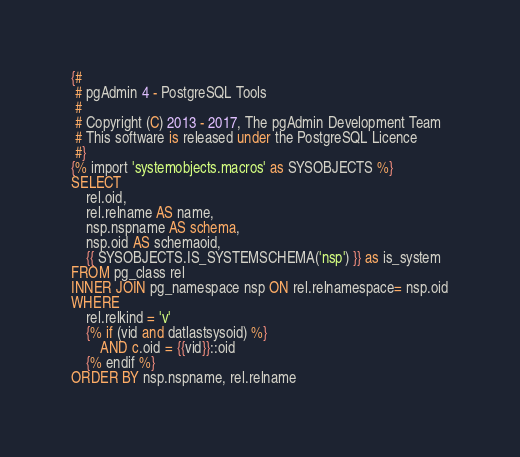Convert code to text. <code><loc_0><loc_0><loc_500><loc_500><_SQL_>{#
 # pgAdmin 4 - PostgreSQL Tools
 #
 # Copyright (C) 2013 - 2017, The pgAdmin Development Team
 # This software is released under the PostgreSQL Licence
 #}
{% import 'systemobjects.macros' as SYSOBJECTS %} 
SELECT
    rel.oid,
    rel.relname AS name,
    nsp.nspname AS schema,
    nsp.oid AS schemaoid,
    {{ SYSOBJECTS.IS_SYSTEMSCHEMA('nsp') }} as is_system
FROM pg_class rel
INNER JOIN pg_namespace nsp ON rel.relnamespace= nsp.oid
WHERE
    rel.relkind = 'v'
    {% if (vid and datlastsysoid) %}
        AND c.oid = {{vid}}::oid
    {% endif %}
ORDER BY nsp.nspname, rel.relname</code> 